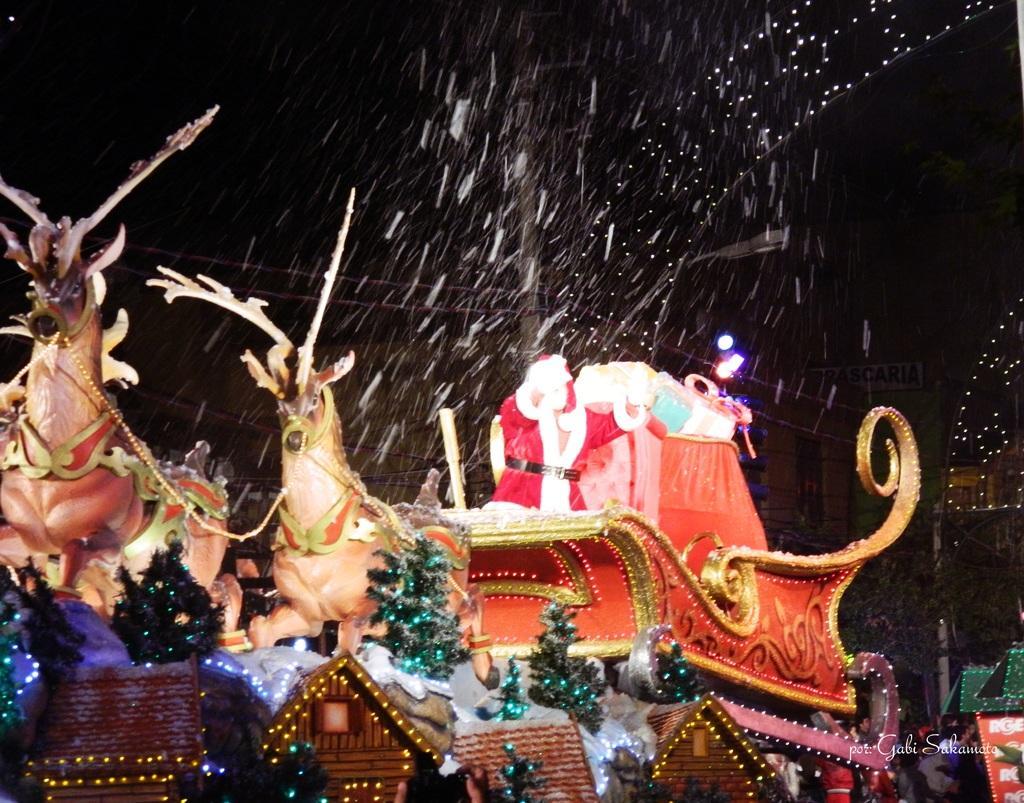How would you summarize this image in a sentence or two? In this image I can see toys, Christmas trees, sculpture of animals, the Santa Claus and other objects. Here I can see houses, lights and a watermark on the image. 